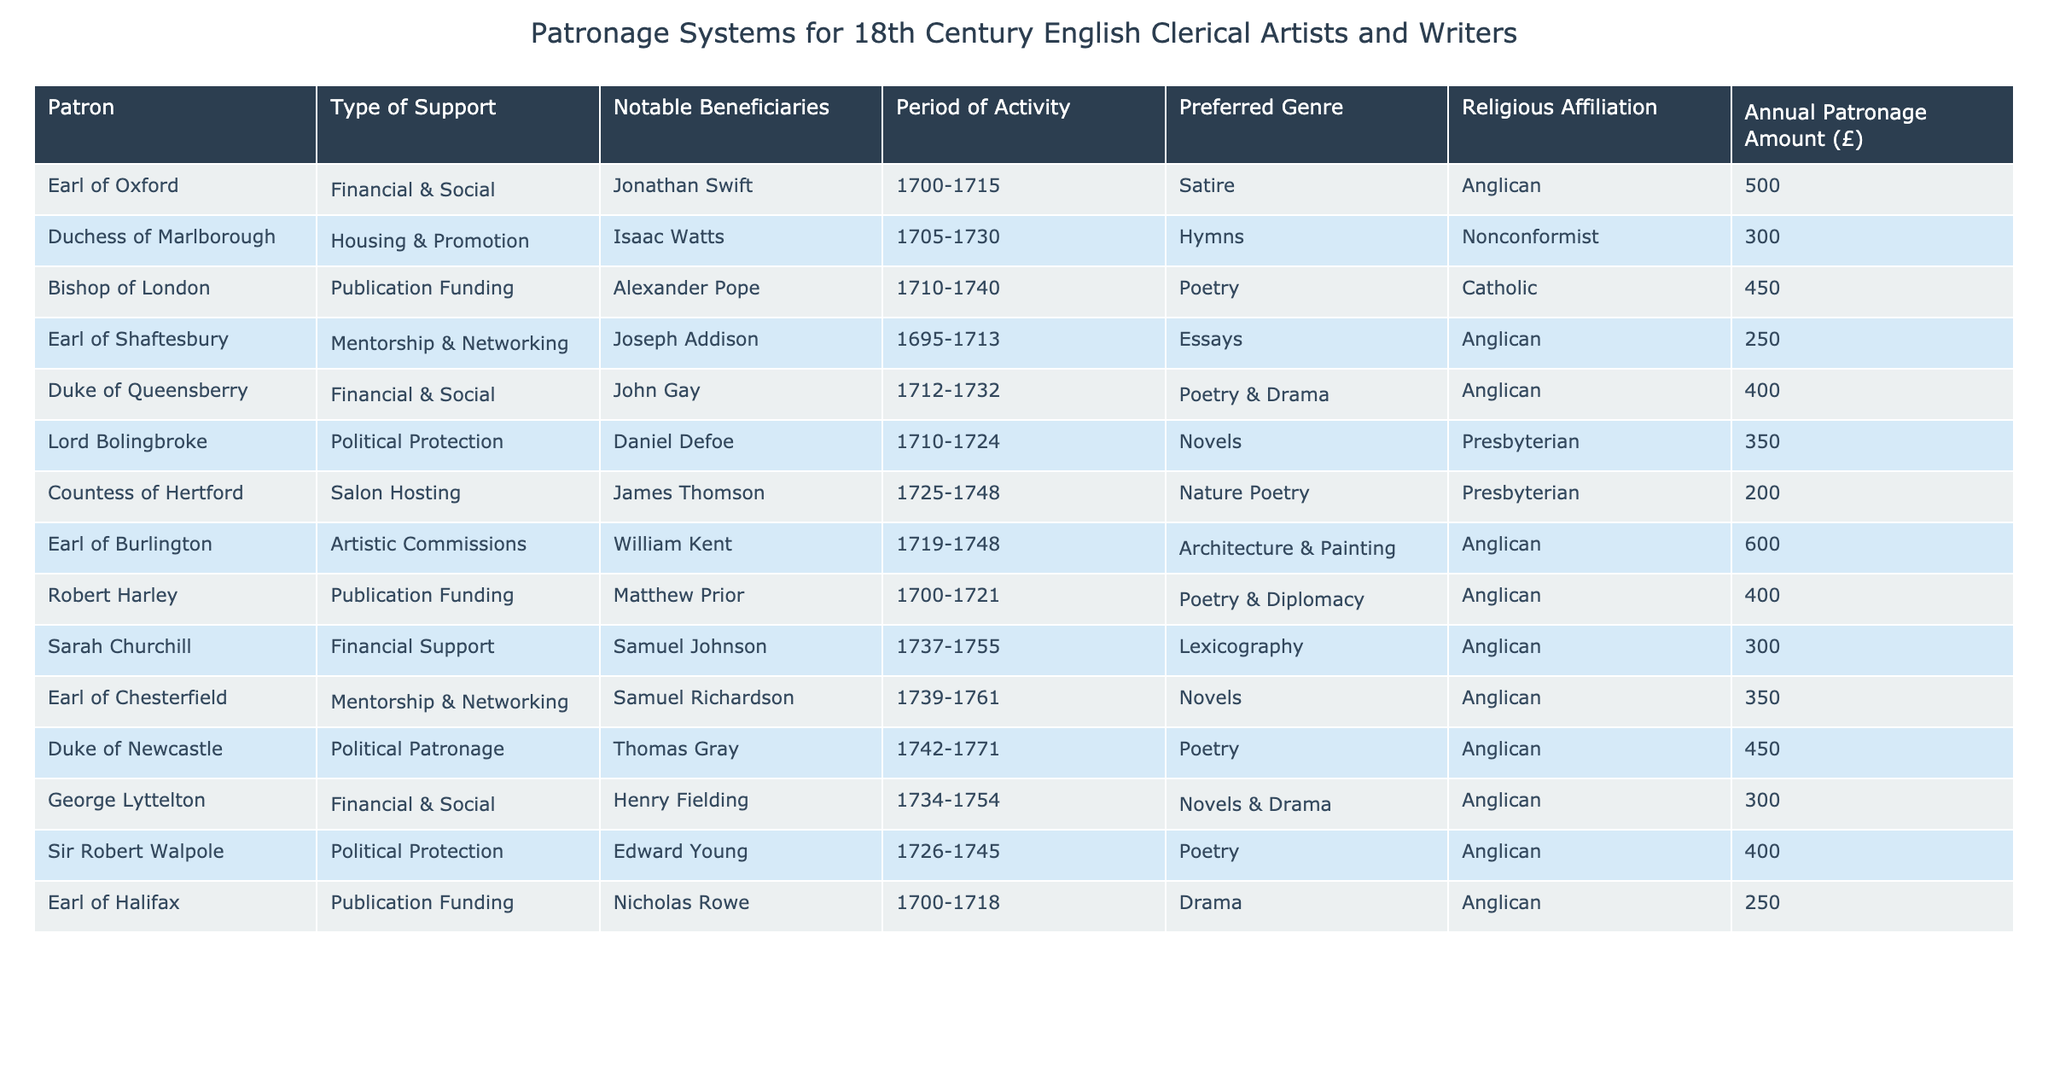What type of support did the Duke of Queensberry provide? According to the table, the Duke of Queensberry provided "Financial & Social" support. This is directly obtained from the "Type of Support" column corresponding to the Duke of Queensberry in the table.
Answer: Financial & Social Who received the highest annual patronage amount? By scanning the "Annual Patronage Amount (£)" column, we see that the Earl of Burlington provided the highest amount at £600. This is determined by comparing all values in that column.
Answer: £600 How many clerical artists and writers had a political patronage type of support? The table lists eight entries, and by reviewing the "Type of Support" column, we can identify that there are three who received "Political Protection" and "Political Patronage." Therefore, the total is three.
Answer: 3 What is the average annual patronage amount for Anglican-affiliated patrons? Focusing on the "Religious Affiliation" column, we see that four entries have "Anglican" affiliation. Their patronage amounts are £500, £400, £300, £350, £450, £300, and £400. Summing these gives £3000. Dividing by the number of Anglican entries (7) gives us 3000/7 = approximately £428.57.
Answer: £428.57 Did any clerical artist or writer associated with the Earl of Halifax have a publication funding? Based on the table, it shows that Nicholas Rowe was the only beneficiary associated with the Earl of Halifax, with a specific support type of "Publication Funding." Thus, the answer is yes.
Answer: Yes Which patron supported the most diverse range of genres? To answer, we need to analyze the "Notable Beneficiaries" and their corresponding "Preferred Genre" types. The Duke of Queensberry supported both poetry and drama, while others have a single genre focus. Finding the maximum diversity leads us to conclude that the Earl of Burlington, supporting architecture and painting, has the most genre variety with two notable fields.
Answer: Earl of Burlington Was there any Nonconformist artist who received housing and promotion? Reviewing the table's "Notable Beneficiaries" with "Housing & Promotion" under the "Type of Support" for Nonconformist reveals Isaac Watts, making the statement true.
Answer: Yes How many patrons provided funding specifically for publication? Upon reviewing the "Type of Support" column, we find four patrons (Bishop of London, Robert Harley, and Earl of Halifax) specifically identified by "Publication Funding." Thus, there are four patrons who provided this type of support.
Answer: 4 